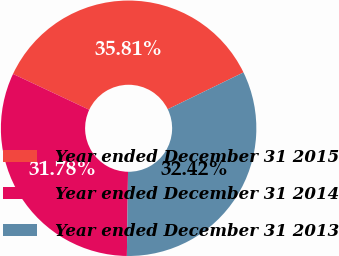Convert chart. <chart><loc_0><loc_0><loc_500><loc_500><pie_chart><fcel>Year ended December 31 2015<fcel>Year ended December 31 2014<fcel>Year ended December 31 2013<nl><fcel>35.81%<fcel>31.78%<fcel>32.42%<nl></chart> 